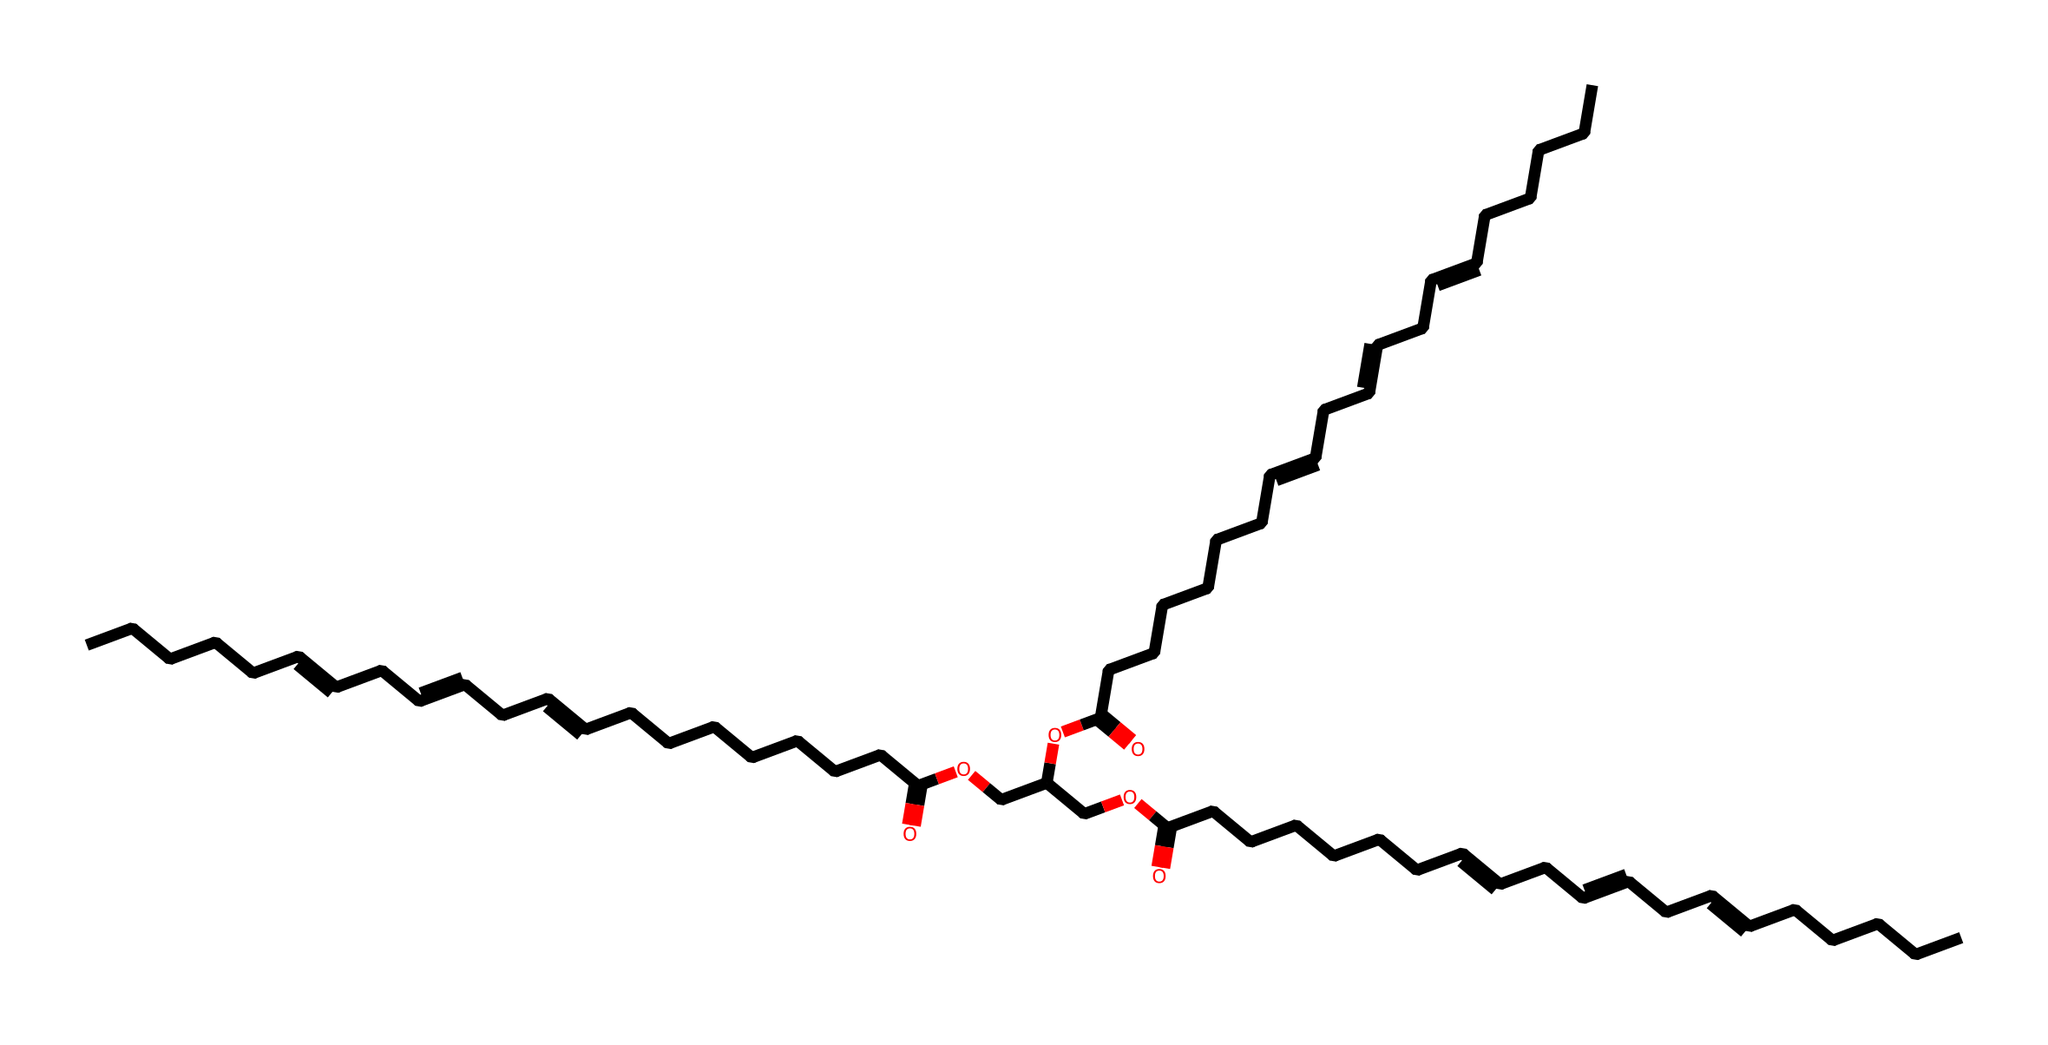What is the total number of carbon atoms in this structure? To determine the total number of carbon atoms in the SMILES representation, count each "C" present in the string. By analyzing the structure, we can identify that there are 36 carbon atoms.
Answer: 36 How many double bonds are present in this compound? By examining the SMILES notation, double bonds are indicated by the "=" symbol. Counting the "=" signs reveals that there are 6 double bonds present in the structure.
Answer: 6 What is the functional group present in this compound that indicates it is an ester? Noticing the "OCC" portions along with the presence of carbonyls (C=O) indicates the presence of ester groups due to the combination of alcohol (alcoholic –OCC) and carboxylic acid portions.
Answer: ester Is this compound likely to be polar or nonpolar? Considering the long chain of hydrocarbon and the presence of the polar functional groups (like ester), the compound will have polar regions due to the esters, but the overall long nonpolar hydrocarbon chains dominate, making it more nonpolar overall.
Answer: nonpolar How many carboxylic acid groups are present in this compound? The presence of "C(=O)O" indicates the carboxylic acid functional groups. By counting these groups in the structure, we find that there are 3 carboxylic acid groups within the chemical.
Answer: 3 What type of fatty acids are represented in this structure? Analyzing the multiple unsaturations (double bonds) in the structure indicates that it contains polyunsaturated fatty acids, specifically omega-3 fatty acids, due to the configuration of the double bonds at certain positions.
Answer: polyunsaturated 